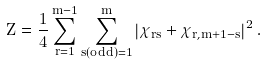Convert formula to latex. <formula><loc_0><loc_0><loc_500><loc_500>Z = \frac { 1 } { 4 } \sum _ { r = 1 } ^ { m - 1 } \sum _ { s ( o d d ) = 1 } ^ { m } \left | \chi _ { r s } + \chi _ { r , m + 1 - s } \right | ^ { 2 } .</formula> 